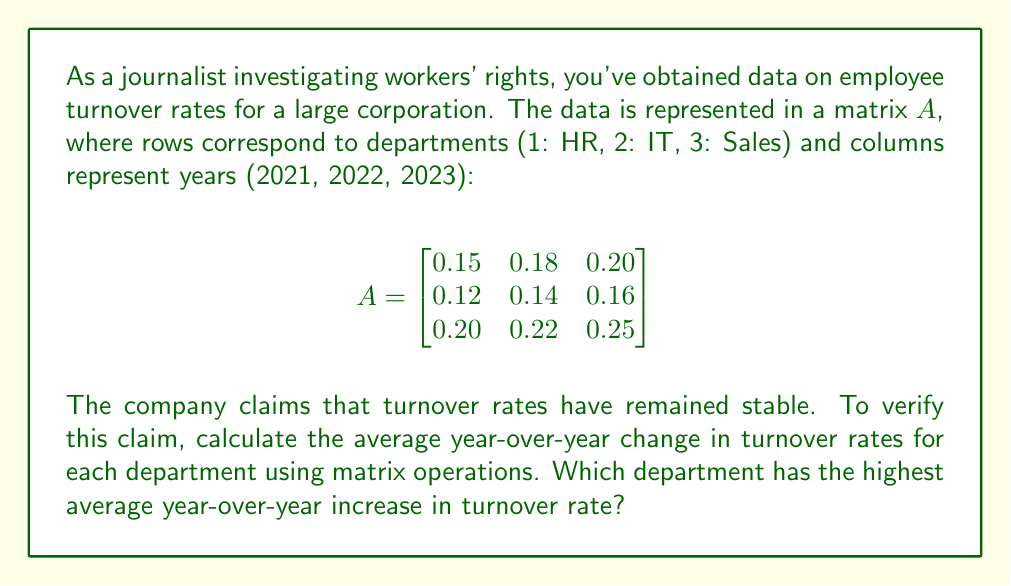Help me with this question. To solve this problem, we'll follow these steps:

1) First, we need to calculate the year-over-year changes. We can do this by subtracting each column from the next column in matrix $A$. Let's call this new matrix $B$:

   $$B = \begin{bmatrix}
   0.18-0.15 & 0.20-0.18 \\
   0.14-0.12 & 0.16-0.14 \\
   0.22-0.20 & 0.25-0.22
   \end{bmatrix} = \begin{bmatrix}
   0.03 & 0.02 \\
   0.02 & 0.02 \\
   0.02 & 0.03
   \end{bmatrix}$$

2) Now, we need to calculate the average of these changes for each department. We can do this by multiplying matrix $B$ by a column vector of $\frac{1}{2}$'s:

   $$C = B \cdot \begin{bmatrix}
   \frac{1}{2} \\
   \frac{1}{2}
   \end{bmatrix} = \begin{bmatrix}
   0.03 \cdot \frac{1}{2} + 0.02 \cdot \frac{1}{2} \\
   0.02 \cdot \frac{1}{2} + 0.02 \cdot \frac{1}{2} \\
   0.02 \cdot \frac{1}{2} + 0.03 \cdot \frac{1}{2}
   \end{bmatrix} = \begin{bmatrix}
   0.025 \\
   0.020 \\
   0.025
   \end{bmatrix}$$

3) The resulting matrix $C$ gives us the average year-over-year change for each department:
   - HR (row 1): 0.025 or 2.5%
   - IT (row 2): 0.020 or 2.0%
   - Sales (row 3): 0.025 or 2.5%

4) The departments with the highest average year-over-year increase are HR and Sales, both with a 2.5% average increase.
Answer: HR and Sales (tie at 2.5% average increase) 